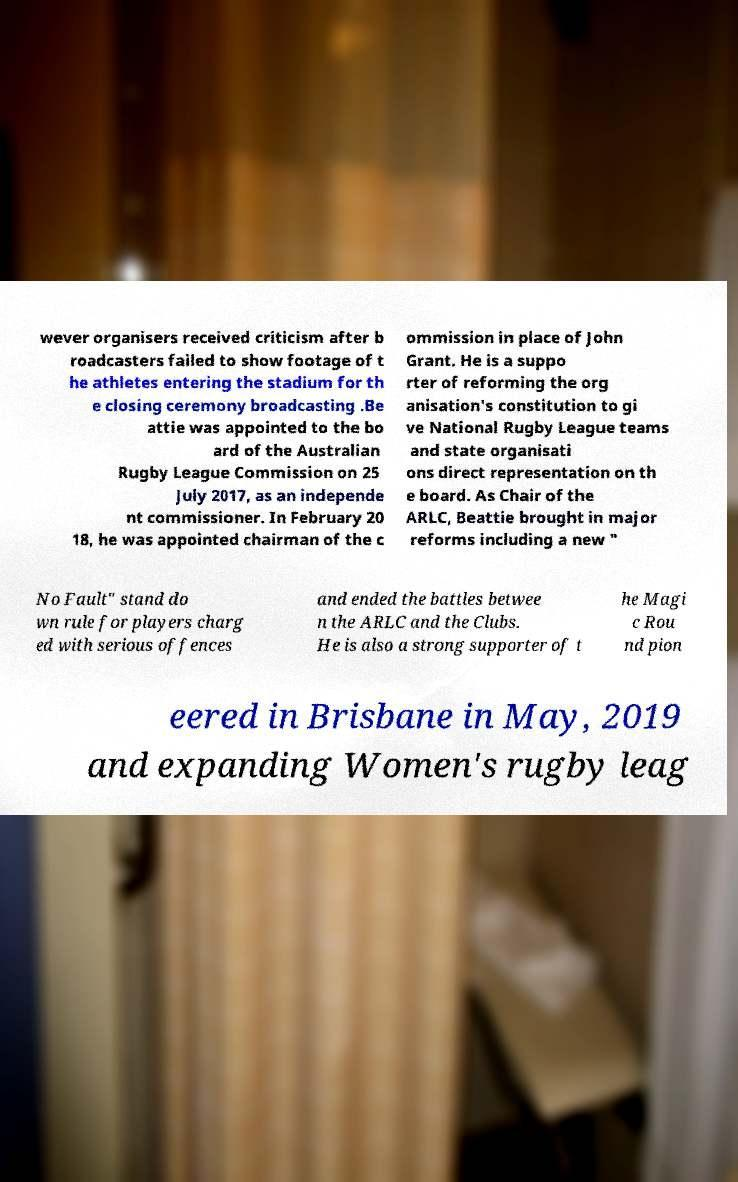Could you assist in decoding the text presented in this image and type it out clearly? wever organisers received criticism after b roadcasters failed to show footage of t he athletes entering the stadium for th e closing ceremony broadcasting .Be attie was appointed to the bo ard of the Australian Rugby League Commission on 25 July 2017, as an independe nt commissioner. In February 20 18, he was appointed chairman of the c ommission in place of John Grant. He is a suppo rter of reforming the org anisation's constitution to gi ve National Rugby League teams and state organisati ons direct representation on th e board. As Chair of the ARLC, Beattie brought in major reforms including a new " No Fault" stand do wn rule for players charg ed with serious offences and ended the battles betwee n the ARLC and the Clubs. He is also a strong supporter of t he Magi c Rou nd pion eered in Brisbane in May, 2019 and expanding Women's rugby leag 